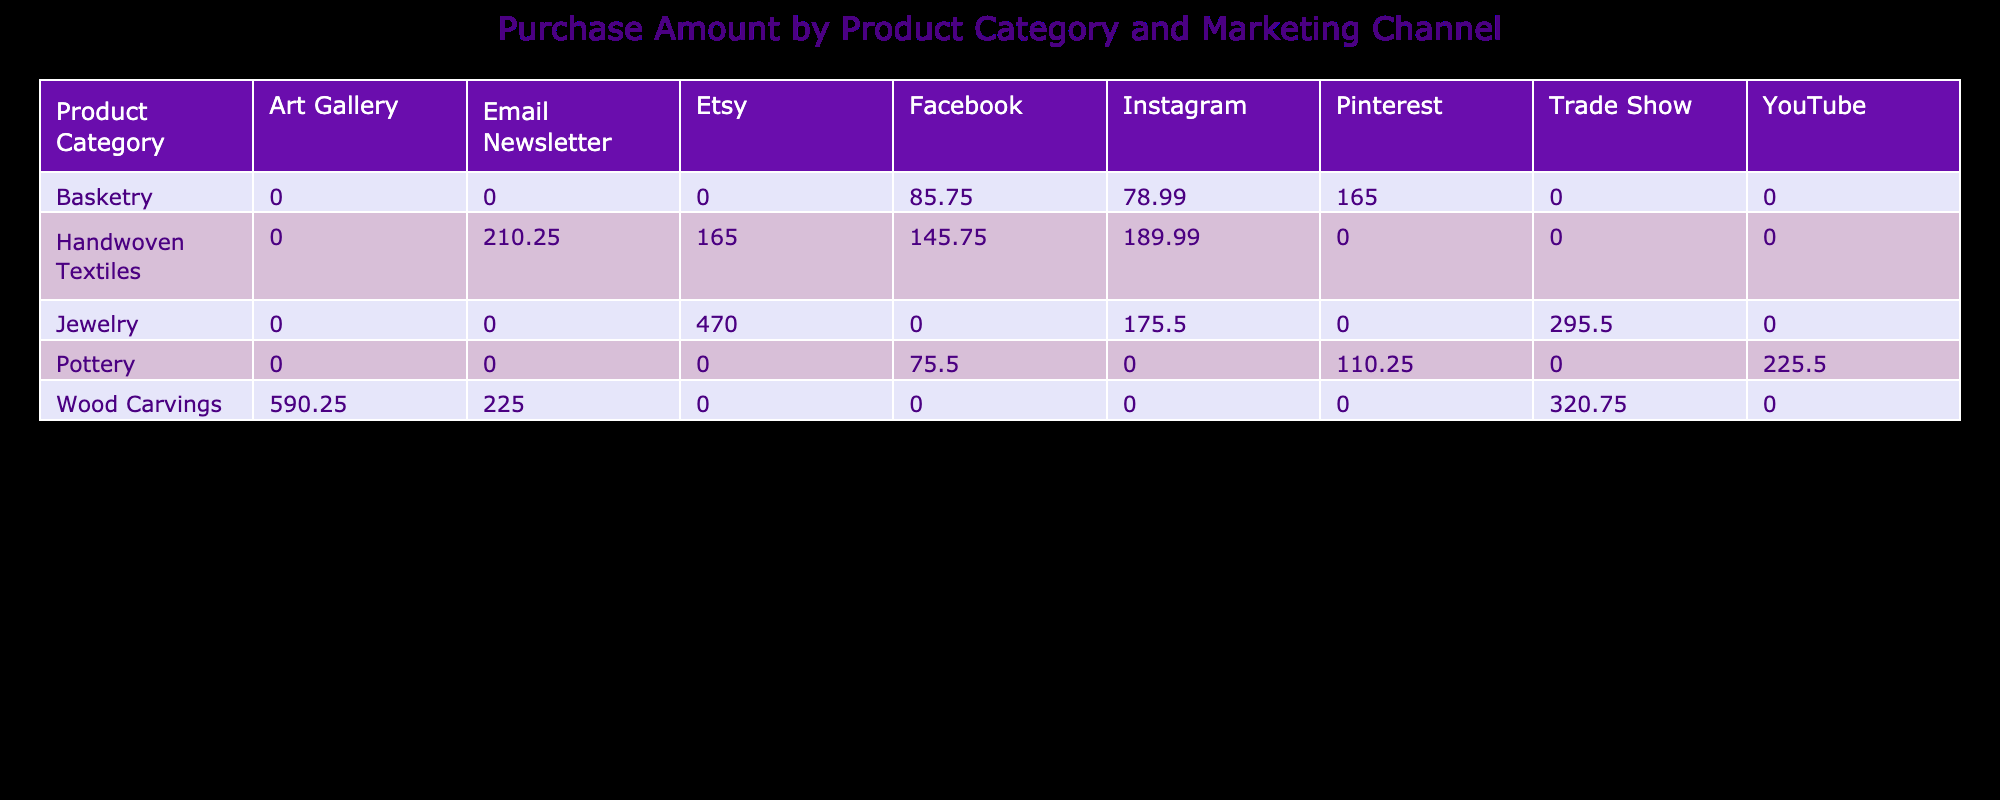What is the total purchase amount for Handwoven Textiles? To find the total purchase amount for Handwoven Textiles, I look for the column labeled "Handwoven Textiles" in the table. The purchase amounts in this column are 189.99, 210.25, and 165.00. Adding these amounts together: 189.99 + 210.25 + 165.00 = 565.24.
Answer: 565.24 Which marketing channel generated the highest sales for Pottery? In the table, I locate the column for Pottery and review the associated marketing channels. The purchase amounts are 75.50 (Facebook), 130.00 (YouTube), and 110.25 (Pinterest). The highest value among these is 130.00 for YouTube.
Answer: YouTube How much more was spent on Jewelry compared to Basketry? I first sum the purchase amounts for Jewelry (250.00 + 295.50 + 220.00) which equals 765.50. Next, I sum for Basketry (95.00 + 85.75 + 78.99 + 70.00) which equals 329.74. Then, I find the difference: 765.50 - 329.74 = 435.76.
Answer: 435.76 Did any Female customers make a purchase through the Email Newsletter? By examining the Email Newsletter column and filtering for Female customers, I see the entries: 210.25 (Female from France) and 165.00 (Female from Brazil). Both indicate that Female customers did make purchases through this channel.
Answer: Yes What is the average purchase amount for Wood Carvings? I note the Wood Carvings amounts from the table, which are 320.75, 280.00, and 225.00. First, I calculate the total: 320.75 + 280.00 + 225.00 = 825.75. Then, I divide the total by the number of purchases (3): 825.75 / 3 = 275.25.
Answer: 275.25 